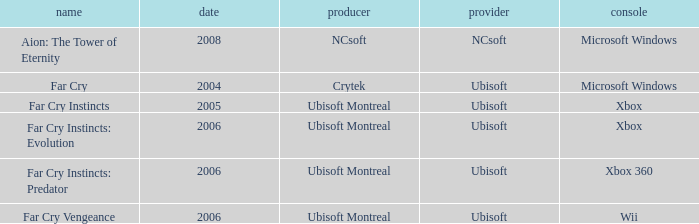Which title has a year prior to 2008 and xbox 360 as the platform? Far Cry Instincts: Predator. 